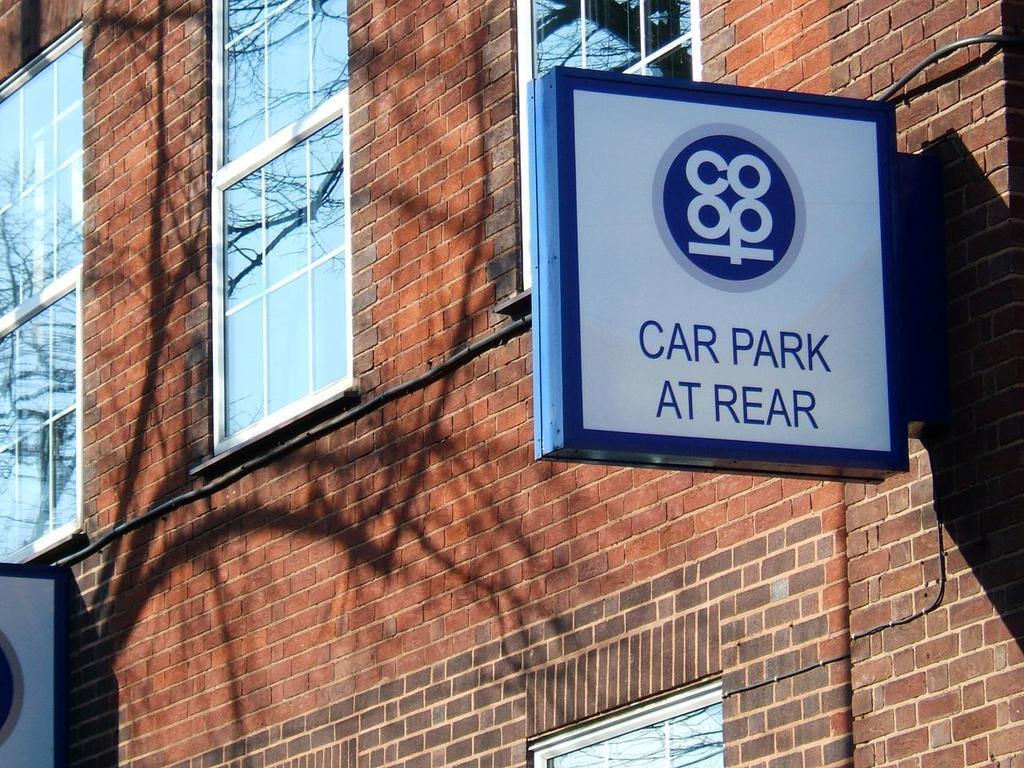How would you summarize this image in a sentence or two? In this picture, we can see the wall with windows, posters, wires on it. 